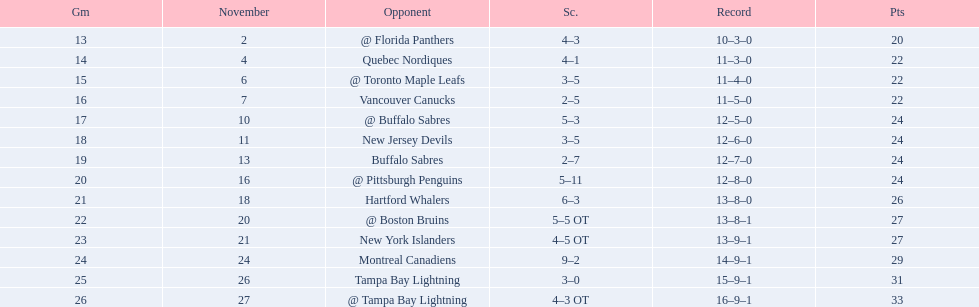What were the scores of the 1993-94 philadelphia flyers season? 4–3, 4–1, 3–5, 2–5, 5–3, 3–5, 2–7, 5–11, 6–3, 5–5 OT, 4–5 OT, 9–2, 3–0, 4–3 OT. Which of these teams had the score 4-5 ot? New York Islanders. 